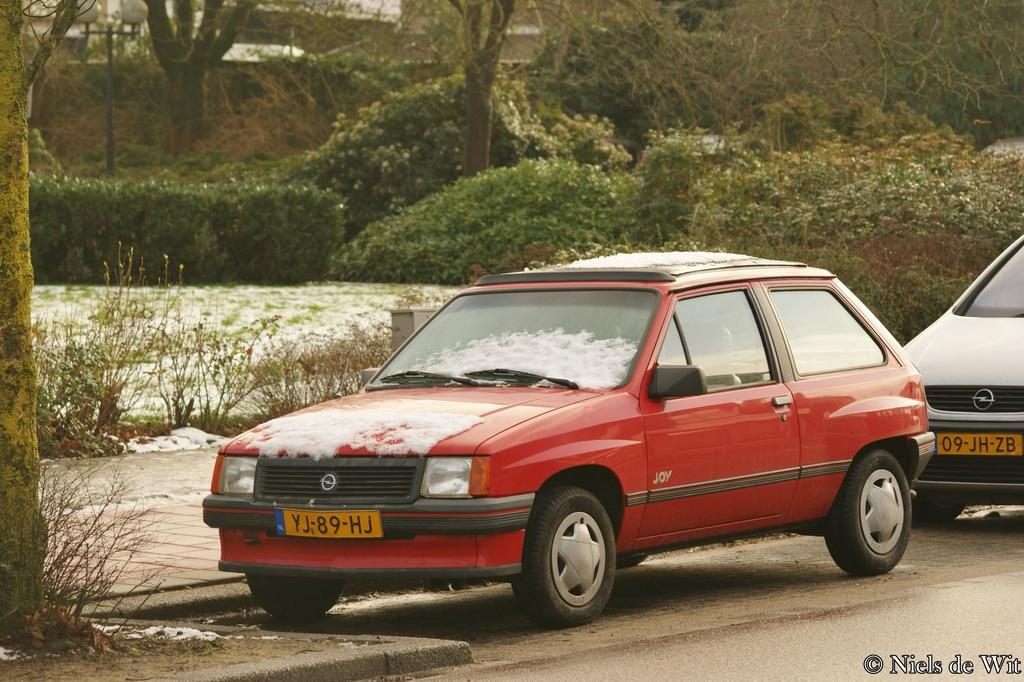What is on the front car's license plate?
Your answer should be very brief. Yj-89-hj. 